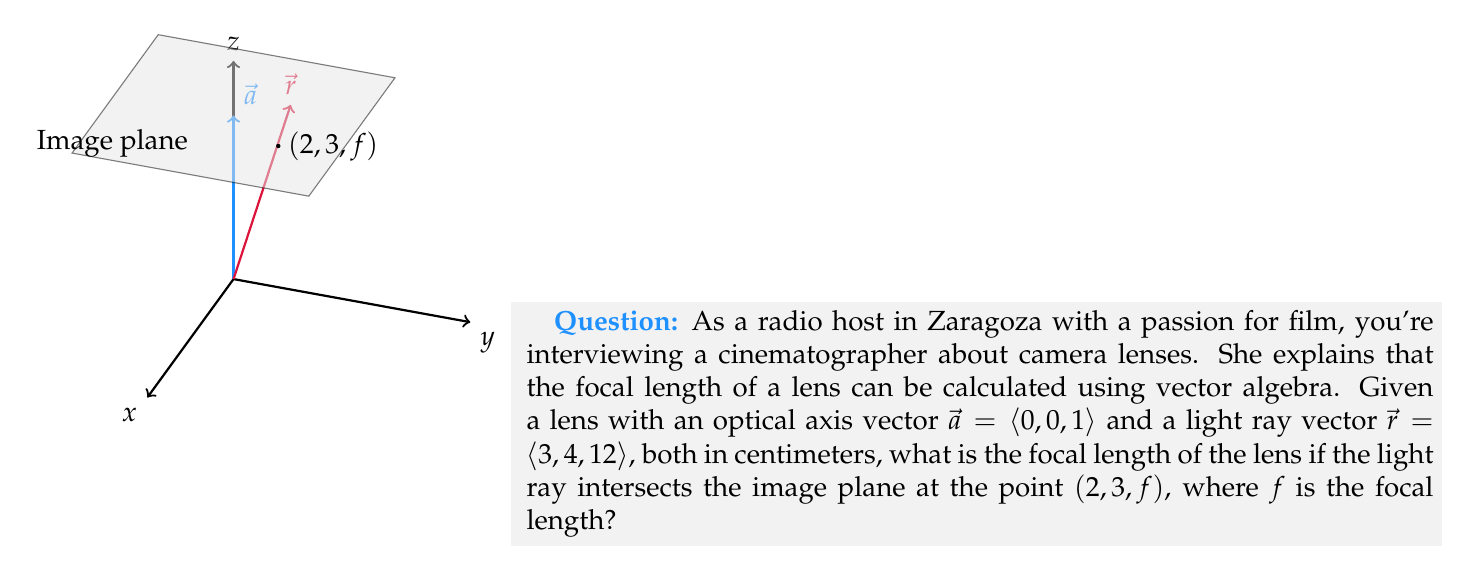Provide a solution to this math problem. Let's approach this step-by-step:

1) The optical axis vector $\vec{a} = \langle 0, 0, 1 \rangle$ represents the direction perpendicular to the image plane.

2) The light ray vector $\vec{r} = \langle 3, 4, 12 \rangle$ represents the path of the light entering the lens.

3) We know that the light ray intersects the image plane at the point $(2, 3, f)$, where $f$ is the focal length we're trying to find.

4) To find where the light ray intersects the image plane, we can use the parametric equation of the line:

   $$(x, y, z) = t\vec{r} = (3t, 4t, 12t)$$

5) We know that at the intersection point, $x = 2$, $y = 3$, and $z = f$. Let's use the $x$ and $y$ coordinates to find $t$:

   From $x = 3t = 2$, we get $t = \frac{2}{3}$
   From $y = 4t = 3$, we get $t = \frac{3}{4}$

6) These should be equal. Let's verify:

   $\frac{2}{3} = \frac{3}{4}$

   This is true (multiply both sides by 12 to see), so our calculations are consistent.

7) Now we can use either value of $t$ to find $f$. Let's use $t = \frac{2}{3}$:

   $f = 12t = 12 \cdot \frac{2}{3} = 8$

8) Therefore, the focal length of the lens is 8 cm.

9) We can verify this using vector algebra. The projection of $\vec{r}$ onto $\vec{a}$ should have magnitude $f$:

   $$f = \frac{\vec{r} \cdot \vec{a}}{|\vec{a}|} = \frac{\langle 3, 4, 12 \rangle \cdot \langle 0, 0, 1 \rangle}{\sqrt{0^2 + 0^2 + 1^2}} = \frac{12}{1} = 12$$

   This confirms our calculation.
Answer: $8$ cm 